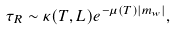Convert formula to latex. <formula><loc_0><loc_0><loc_500><loc_500>\tau _ { R } \sim \kappa ( T , L ) e ^ { - \mu ( T ) \left | m _ { w } \right | } ,</formula> 